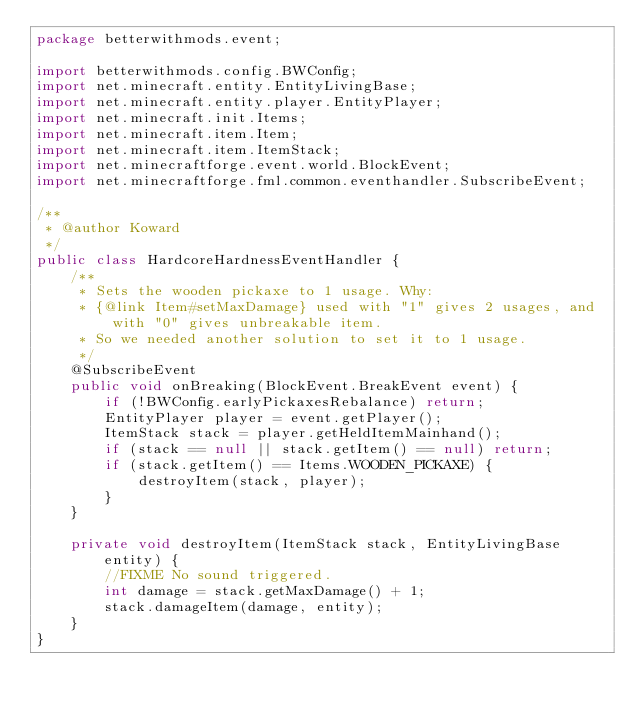<code> <loc_0><loc_0><loc_500><loc_500><_Java_>package betterwithmods.event;

import betterwithmods.config.BWConfig;
import net.minecraft.entity.EntityLivingBase;
import net.minecraft.entity.player.EntityPlayer;
import net.minecraft.init.Items;
import net.minecraft.item.Item;
import net.minecraft.item.ItemStack;
import net.minecraftforge.event.world.BlockEvent;
import net.minecraftforge.fml.common.eventhandler.SubscribeEvent;

/**
 * @author Koward
 */
public class HardcoreHardnessEventHandler {
    /**
     * Sets the wooden pickaxe to 1 usage. Why:
     * {@link Item#setMaxDamage} used with "1" gives 2 usages, and with "0" gives unbreakable item.
     * So we needed another solution to set it to 1 usage.
     */
    @SubscribeEvent
    public void onBreaking(BlockEvent.BreakEvent event) {
        if (!BWConfig.earlyPickaxesRebalance) return;
        EntityPlayer player = event.getPlayer();
        ItemStack stack = player.getHeldItemMainhand();
        if (stack == null || stack.getItem() == null) return;
        if (stack.getItem() == Items.WOODEN_PICKAXE) {
            destroyItem(stack, player);
        }
    }

    private void destroyItem(ItemStack stack, EntityLivingBase entity) {
        //FIXME No sound triggered.
        int damage = stack.getMaxDamage() + 1;
        stack.damageItem(damage, entity);
    }
}
</code> 